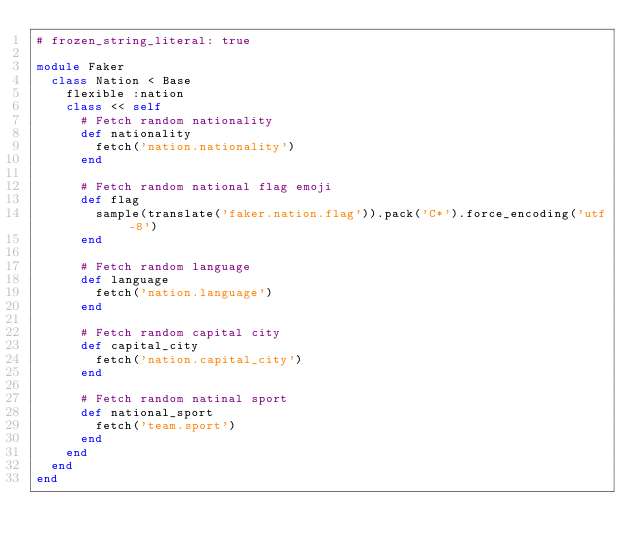<code> <loc_0><loc_0><loc_500><loc_500><_Ruby_># frozen_string_literal: true

module Faker
  class Nation < Base
    flexible :nation
    class << self
      # Fetch random nationality
      def nationality
        fetch('nation.nationality')
      end

      # Fetch random national flag emoji
      def flag
        sample(translate('faker.nation.flag')).pack('C*').force_encoding('utf-8')
      end

      # Fetch random language
      def language
        fetch('nation.language')
      end

      # Fetch random capital city
      def capital_city
        fetch('nation.capital_city')
      end

      # Fetch random natinal sport
      def national_sport
        fetch('team.sport')
      end
    end
  end
end
</code> 